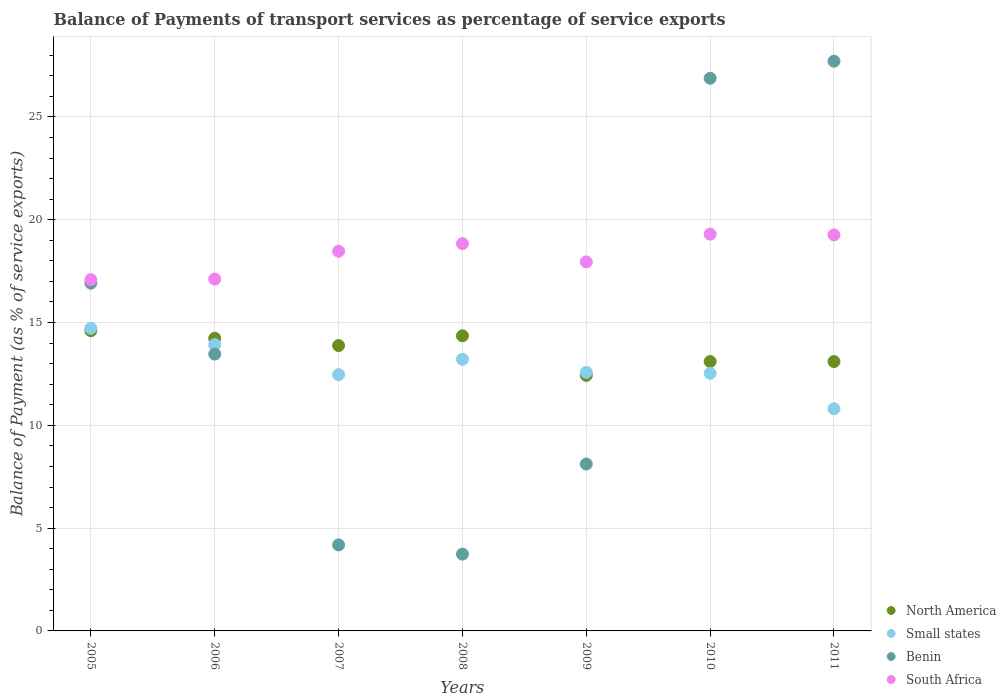What is the balance of payments of transport services in North America in 2010?
Your answer should be very brief. 13.1. Across all years, what is the maximum balance of payments of transport services in South Africa?
Provide a short and direct response. 19.3. Across all years, what is the minimum balance of payments of transport services in North America?
Your answer should be compact. 12.43. In which year was the balance of payments of transport services in North America maximum?
Keep it short and to the point. 2005. What is the total balance of payments of transport services in North America in the graph?
Your answer should be compact. 95.7. What is the difference between the balance of payments of transport services in Benin in 2005 and that in 2008?
Offer a terse response. 13.18. What is the difference between the balance of payments of transport services in Benin in 2005 and the balance of payments of transport services in South Africa in 2008?
Provide a succinct answer. -1.92. What is the average balance of payments of transport services in South Africa per year?
Ensure brevity in your answer.  18.29. In the year 2008, what is the difference between the balance of payments of transport services in Benin and balance of payments of transport services in Small states?
Ensure brevity in your answer.  -9.47. In how many years, is the balance of payments of transport services in South Africa greater than 8 %?
Offer a very short reply. 7. What is the ratio of the balance of payments of transport services in Small states in 2008 to that in 2009?
Ensure brevity in your answer.  1.05. Is the balance of payments of transport services in South Africa in 2008 less than that in 2010?
Offer a terse response. Yes. What is the difference between the highest and the second highest balance of payments of transport services in North America?
Make the answer very short. 0.24. What is the difference between the highest and the lowest balance of payments of transport services in Small states?
Keep it short and to the point. 3.91. Is it the case that in every year, the sum of the balance of payments of transport services in North America and balance of payments of transport services in Small states  is greater than the sum of balance of payments of transport services in Benin and balance of payments of transport services in South Africa?
Your answer should be very brief. Yes. Is it the case that in every year, the sum of the balance of payments of transport services in North America and balance of payments of transport services in South Africa  is greater than the balance of payments of transport services in Benin?
Offer a very short reply. Yes. Is the balance of payments of transport services in South Africa strictly greater than the balance of payments of transport services in Benin over the years?
Keep it short and to the point. No. Is the balance of payments of transport services in Small states strictly less than the balance of payments of transport services in North America over the years?
Offer a very short reply. No. How many dotlines are there?
Offer a very short reply. 4. Are the values on the major ticks of Y-axis written in scientific E-notation?
Give a very brief answer. No. What is the title of the graph?
Keep it short and to the point. Balance of Payments of transport services as percentage of service exports. What is the label or title of the Y-axis?
Keep it short and to the point. Balance of Payment (as % of service exports). What is the Balance of Payment (as % of service exports) of North America in 2005?
Keep it short and to the point. 14.6. What is the Balance of Payment (as % of service exports) of Small states in 2005?
Your answer should be very brief. 14.72. What is the Balance of Payment (as % of service exports) in Benin in 2005?
Offer a terse response. 16.92. What is the Balance of Payment (as % of service exports) of South Africa in 2005?
Make the answer very short. 17.08. What is the Balance of Payment (as % of service exports) in North America in 2006?
Provide a short and direct response. 14.23. What is the Balance of Payment (as % of service exports) of Small states in 2006?
Provide a short and direct response. 13.92. What is the Balance of Payment (as % of service exports) in Benin in 2006?
Your response must be concise. 13.46. What is the Balance of Payment (as % of service exports) of South Africa in 2006?
Your answer should be very brief. 17.11. What is the Balance of Payment (as % of service exports) in North America in 2007?
Keep it short and to the point. 13.88. What is the Balance of Payment (as % of service exports) in Small states in 2007?
Make the answer very short. 12.46. What is the Balance of Payment (as % of service exports) of Benin in 2007?
Provide a succinct answer. 4.18. What is the Balance of Payment (as % of service exports) in South Africa in 2007?
Provide a short and direct response. 18.47. What is the Balance of Payment (as % of service exports) in North America in 2008?
Give a very brief answer. 14.35. What is the Balance of Payment (as % of service exports) in Small states in 2008?
Your answer should be very brief. 13.21. What is the Balance of Payment (as % of service exports) in Benin in 2008?
Your answer should be compact. 3.73. What is the Balance of Payment (as % of service exports) of South Africa in 2008?
Ensure brevity in your answer.  18.84. What is the Balance of Payment (as % of service exports) of North America in 2009?
Offer a terse response. 12.43. What is the Balance of Payment (as % of service exports) in Small states in 2009?
Your answer should be very brief. 12.58. What is the Balance of Payment (as % of service exports) of Benin in 2009?
Offer a very short reply. 8.12. What is the Balance of Payment (as % of service exports) in South Africa in 2009?
Your answer should be compact. 17.95. What is the Balance of Payment (as % of service exports) in North America in 2010?
Make the answer very short. 13.1. What is the Balance of Payment (as % of service exports) in Small states in 2010?
Your answer should be compact. 12.53. What is the Balance of Payment (as % of service exports) of Benin in 2010?
Provide a succinct answer. 26.88. What is the Balance of Payment (as % of service exports) in South Africa in 2010?
Make the answer very short. 19.3. What is the Balance of Payment (as % of service exports) in North America in 2011?
Provide a succinct answer. 13.1. What is the Balance of Payment (as % of service exports) of Small states in 2011?
Offer a terse response. 10.81. What is the Balance of Payment (as % of service exports) in Benin in 2011?
Your answer should be compact. 27.71. What is the Balance of Payment (as % of service exports) in South Africa in 2011?
Your answer should be very brief. 19.26. Across all years, what is the maximum Balance of Payment (as % of service exports) of North America?
Provide a short and direct response. 14.6. Across all years, what is the maximum Balance of Payment (as % of service exports) in Small states?
Your response must be concise. 14.72. Across all years, what is the maximum Balance of Payment (as % of service exports) in Benin?
Provide a short and direct response. 27.71. Across all years, what is the maximum Balance of Payment (as % of service exports) in South Africa?
Provide a short and direct response. 19.3. Across all years, what is the minimum Balance of Payment (as % of service exports) in North America?
Your answer should be compact. 12.43. Across all years, what is the minimum Balance of Payment (as % of service exports) in Small states?
Make the answer very short. 10.81. Across all years, what is the minimum Balance of Payment (as % of service exports) of Benin?
Offer a very short reply. 3.73. Across all years, what is the minimum Balance of Payment (as % of service exports) in South Africa?
Give a very brief answer. 17.08. What is the total Balance of Payment (as % of service exports) in North America in the graph?
Your answer should be compact. 95.7. What is the total Balance of Payment (as % of service exports) in Small states in the graph?
Your answer should be compact. 90.23. What is the total Balance of Payment (as % of service exports) of Benin in the graph?
Offer a terse response. 101.01. What is the total Balance of Payment (as % of service exports) in South Africa in the graph?
Provide a succinct answer. 128.01. What is the difference between the Balance of Payment (as % of service exports) of North America in 2005 and that in 2006?
Make the answer very short. 0.37. What is the difference between the Balance of Payment (as % of service exports) in Small states in 2005 and that in 2006?
Your response must be concise. 0.8. What is the difference between the Balance of Payment (as % of service exports) in Benin in 2005 and that in 2006?
Keep it short and to the point. 3.45. What is the difference between the Balance of Payment (as % of service exports) in South Africa in 2005 and that in 2006?
Provide a succinct answer. -0.03. What is the difference between the Balance of Payment (as % of service exports) in North America in 2005 and that in 2007?
Your answer should be compact. 0.72. What is the difference between the Balance of Payment (as % of service exports) of Small states in 2005 and that in 2007?
Provide a short and direct response. 2.26. What is the difference between the Balance of Payment (as % of service exports) of Benin in 2005 and that in 2007?
Offer a very short reply. 12.73. What is the difference between the Balance of Payment (as % of service exports) in South Africa in 2005 and that in 2007?
Provide a short and direct response. -1.38. What is the difference between the Balance of Payment (as % of service exports) in North America in 2005 and that in 2008?
Offer a terse response. 0.24. What is the difference between the Balance of Payment (as % of service exports) of Small states in 2005 and that in 2008?
Your answer should be very brief. 1.51. What is the difference between the Balance of Payment (as % of service exports) in Benin in 2005 and that in 2008?
Offer a very short reply. 13.18. What is the difference between the Balance of Payment (as % of service exports) of South Africa in 2005 and that in 2008?
Offer a very short reply. -1.75. What is the difference between the Balance of Payment (as % of service exports) of North America in 2005 and that in 2009?
Ensure brevity in your answer.  2.17. What is the difference between the Balance of Payment (as % of service exports) in Small states in 2005 and that in 2009?
Ensure brevity in your answer.  2.14. What is the difference between the Balance of Payment (as % of service exports) of Benin in 2005 and that in 2009?
Provide a succinct answer. 8.8. What is the difference between the Balance of Payment (as % of service exports) in South Africa in 2005 and that in 2009?
Provide a short and direct response. -0.87. What is the difference between the Balance of Payment (as % of service exports) in North America in 2005 and that in 2010?
Your response must be concise. 1.5. What is the difference between the Balance of Payment (as % of service exports) of Small states in 2005 and that in 2010?
Provide a succinct answer. 2.19. What is the difference between the Balance of Payment (as % of service exports) in Benin in 2005 and that in 2010?
Keep it short and to the point. -9.96. What is the difference between the Balance of Payment (as % of service exports) of South Africa in 2005 and that in 2010?
Give a very brief answer. -2.21. What is the difference between the Balance of Payment (as % of service exports) in North America in 2005 and that in 2011?
Make the answer very short. 1.5. What is the difference between the Balance of Payment (as % of service exports) in Small states in 2005 and that in 2011?
Provide a succinct answer. 3.91. What is the difference between the Balance of Payment (as % of service exports) of Benin in 2005 and that in 2011?
Give a very brief answer. -10.79. What is the difference between the Balance of Payment (as % of service exports) in South Africa in 2005 and that in 2011?
Provide a succinct answer. -2.18. What is the difference between the Balance of Payment (as % of service exports) in North America in 2006 and that in 2007?
Make the answer very short. 0.35. What is the difference between the Balance of Payment (as % of service exports) in Small states in 2006 and that in 2007?
Your answer should be compact. 1.46. What is the difference between the Balance of Payment (as % of service exports) of Benin in 2006 and that in 2007?
Make the answer very short. 9.28. What is the difference between the Balance of Payment (as % of service exports) of South Africa in 2006 and that in 2007?
Make the answer very short. -1.35. What is the difference between the Balance of Payment (as % of service exports) in North America in 2006 and that in 2008?
Offer a terse response. -0.12. What is the difference between the Balance of Payment (as % of service exports) in Small states in 2006 and that in 2008?
Provide a short and direct response. 0.71. What is the difference between the Balance of Payment (as % of service exports) of Benin in 2006 and that in 2008?
Your response must be concise. 9.73. What is the difference between the Balance of Payment (as % of service exports) in South Africa in 2006 and that in 2008?
Ensure brevity in your answer.  -1.72. What is the difference between the Balance of Payment (as % of service exports) of North America in 2006 and that in 2009?
Your answer should be compact. 1.8. What is the difference between the Balance of Payment (as % of service exports) of Small states in 2006 and that in 2009?
Offer a terse response. 1.35. What is the difference between the Balance of Payment (as % of service exports) in Benin in 2006 and that in 2009?
Provide a short and direct response. 5.35. What is the difference between the Balance of Payment (as % of service exports) in South Africa in 2006 and that in 2009?
Offer a very short reply. -0.83. What is the difference between the Balance of Payment (as % of service exports) of North America in 2006 and that in 2010?
Offer a terse response. 1.13. What is the difference between the Balance of Payment (as % of service exports) of Small states in 2006 and that in 2010?
Your answer should be compact. 1.39. What is the difference between the Balance of Payment (as % of service exports) in Benin in 2006 and that in 2010?
Keep it short and to the point. -13.42. What is the difference between the Balance of Payment (as % of service exports) of South Africa in 2006 and that in 2010?
Offer a very short reply. -2.18. What is the difference between the Balance of Payment (as % of service exports) in North America in 2006 and that in 2011?
Make the answer very short. 1.13. What is the difference between the Balance of Payment (as % of service exports) of Small states in 2006 and that in 2011?
Keep it short and to the point. 3.12. What is the difference between the Balance of Payment (as % of service exports) in Benin in 2006 and that in 2011?
Offer a very short reply. -14.25. What is the difference between the Balance of Payment (as % of service exports) of South Africa in 2006 and that in 2011?
Give a very brief answer. -2.15. What is the difference between the Balance of Payment (as % of service exports) of North America in 2007 and that in 2008?
Offer a very short reply. -0.48. What is the difference between the Balance of Payment (as % of service exports) of Small states in 2007 and that in 2008?
Provide a succinct answer. -0.75. What is the difference between the Balance of Payment (as % of service exports) of Benin in 2007 and that in 2008?
Your response must be concise. 0.45. What is the difference between the Balance of Payment (as % of service exports) of South Africa in 2007 and that in 2008?
Provide a succinct answer. -0.37. What is the difference between the Balance of Payment (as % of service exports) of North America in 2007 and that in 2009?
Make the answer very short. 1.45. What is the difference between the Balance of Payment (as % of service exports) of Small states in 2007 and that in 2009?
Your response must be concise. -0.11. What is the difference between the Balance of Payment (as % of service exports) of Benin in 2007 and that in 2009?
Offer a terse response. -3.94. What is the difference between the Balance of Payment (as % of service exports) of South Africa in 2007 and that in 2009?
Offer a terse response. 0.52. What is the difference between the Balance of Payment (as % of service exports) of North America in 2007 and that in 2010?
Make the answer very short. 0.78. What is the difference between the Balance of Payment (as % of service exports) in Small states in 2007 and that in 2010?
Keep it short and to the point. -0.07. What is the difference between the Balance of Payment (as % of service exports) of Benin in 2007 and that in 2010?
Give a very brief answer. -22.7. What is the difference between the Balance of Payment (as % of service exports) in South Africa in 2007 and that in 2010?
Your answer should be very brief. -0.83. What is the difference between the Balance of Payment (as % of service exports) of North America in 2007 and that in 2011?
Ensure brevity in your answer.  0.78. What is the difference between the Balance of Payment (as % of service exports) in Small states in 2007 and that in 2011?
Make the answer very short. 1.66. What is the difference between the Balance of Payment (as % of service exports) in Benin in 2007 and that in 2011?
Your response must be concise. -23.53. What is the difference between the Balance of Payment (as % of service exports) in South Africa in 2007 and that in 2011?
Your response must be concise. -0.79. What is the difference between the Balance of Payment (as % of service exports) in North America in 2008 and that in 2009?
Keep it short and to the point. 1.93. What is the difference between the Balance of Payment (as % of service exports) of Small states in 2008 and that in 2009?
Your answer should be very brief. 0.63. What is the difference between the Balance of Payment (as % of service exports) of Benin in 2008 and that in 2009?
Your answer should be compact. -4.38. What is the difference between the Balance of Payment (as % of service exports) in South Africa in 2008 and that in 2009?
Give a very brief answer. 0.89. What is the difference between the Balance of Payment (as % of service exports) in North America in 2008 and that in 2010?
Provide a short and direct response. 1.25. What is the difference between the Balance of Payment (as % of service exports) in Small states in 2008 and that in 2010?
Offer a terse response. 0.68. What is the difference between the Balance of Payment (as % of service exports) in Benin in 2008 and that in 2010?
Make the answer very short. -23.15. What is the difference between the Balance of Payment (as % of service exports) in South Africa in 2008 and that in 2010?
Provide a succinct answer. -0.46. What is the difference between the Balance of Payment (as % of service exports) in North America in 2008 and that in 2011?
Your response must be concise. 1.25. What is the difference between the Balance of Payment (as % of service exports) of Small states in 2008 and that in 2011?
Keep it short and to the point. 2.4. What is the difference between the Balance of Payment (as % of service exports) of Benin in 2008 and that in 2011?
Keep it short and to the point. -23.97. What is the difference between the Balance of Payment (as % of service exports) in South Africa in 2008 and that in 2011?
Give a very brief answer. -0.43. What is the difference between the Balance of Payment (as % of service exports) in North America in 2009 and that in 2010?
Your answer should be very brief. -0.67. What is the difference between the Balance of Payment (as % of service exports) in Small states in 2009 and that in 2010?
Make the answer very short. 0.04. What is the difference between the Balance of Payment (as % of service exports) of Benin in 2009 and that in 2010?
Your answer should be very brief. -18.76. What is the difference between the Balance of Payment (as % of service exports) of South Africa in 2009 and that in 2010?
Your answer should be very brief. -1.35. What is the difference between the Balance of Payment (as % of service exports) of North America in 2009 and that in 2011?
Your answer should be compact. -0.67. What is the difference between the Balance of Payment (as % of service exports) in Small states in 2009 and that in 2011?
Offer a very short reply. 1.77. What is the difference between the Balance of Payment (as % of service exports) of Benin in 2009 and that in 2011?
Offer a terse response. -19.59. What is the difference between the Balance of Payment (as % of service exports) of South Africa in 2009 and that in 2011?
Provide a short and direct response. -1.31. What is the difference between the Balance of Payment (as % of service exports) in North America in 2010 and that in 2011?
Give a very brief answer. 0. What is the difference between the Balance of Payment (as % of service exports) of Small states in 2010 and that in 2011?
Offer a terse response. 1.73. What is the difference between the Balance of Payment (as % of service exports) of Benin in 2010 and that in 2011?
Offer a terse response. -0.83. What is the difference between the Balance of Payment (as % of service exports) of South Africa in 2010 and that in 2011?
Keep it short and to the point. 0.03. What is the difference between the Balance of Payment (as % of service exports) in North America in 2005 and the Balance of Payment (as % of service exports) in Small states in 2006?
Provide a succinct answer. 0.68. What is the difference between the Balance of Payment (as % of service exports) in North America in 2005 and the Balance of Payment (as % of service exports) in Benin in 2006?
Give a very brief answer. 1.13. What is the difference between the Balance of Payment (as % of service exports) of North America in 2005 and the Balance of Payment (as % of service exports) of South Africa in 2006?
Your response must be concise. -2.52. What is the difference between the Balance of Payment (as % of service exports) of Small states in 2005 and the Balance of Payment (as % of service exports) of Benin in 2006?
Keep it short and to the point. 1.26. What is the difference between the Balance of Payment (as % of service exports) in Small states in 2005 and the Balance of Payment (as % of service exports) in South Africa in 2006?
Your response must be concise. -2.39. What is the difference between the Balance of Payment (as % of service exports) of Benin in 2005 and the Balance of Payment (as % of service exports) of South Africa in 2006?
Keep it short and to the point. -0.2. What is the difference between the Balance of Payment (as % of service exports) in North America in 2005 and the Balance of Payment (as % of service exports) in Small states in 2007?
Make the answer very short. 2.13. What is the difference between the Balance of Payment (as % of service exports) of North America in 2005 and the Balance of Payment (as % of service exports) of Benin in 2007?
Provide a short and direct response. 10.42. What is the difference between the Balance of Payment (as % of service exports) in North America in 2005 and the Balance of Payment (as % of service exports) in South Africa in 2007?
Offer a very short reply. -3.87. What is the difference between the Balance of Payment (as % of service exports) of Small states in 2005 and the Balance of Payment (as % of service exports) of Benin in 2007?
Offer a very short reply. 10.54. What is the difference between the Balance of Payment (as % of service exports) of Small states in 2005 and the Balance of Payment (as % of service exports) of South Africa in 2007?
Your response must be concise. -3.75. What is the difference between the Balance of Payment (as % of service exports) of Benin in 2005 and the Balance of Payment (as % of service exports) of South Africa in 2007?
Your response must be concise. -1.55. What is the difference between the Balance of Payment (as % of service exports) in North America in 2005 and the Balance of Payment (as % of service exports) in Small states in 2008?
Your answer should be compact. 1.39. What is the difference between the Balance of Payment (as % of service exports) of North America in 2005 and the Balance of Payment (as % of service exports) of Benin in 2008?
Ensure brevity in your answer.  10.86. What is the difference between the Balance of Payment (as % of service exports) in North America in 2005 and the Balance of Payment (as % of service exports) in South Africa in 2008?
Provide a short and direct response. -4.24. What is the difference between the Balance of Payment (as % of service exports) of Small states in 2005 and the Balance of Payment (as % of service exports) of Benin in 2008?
Keep it short and to the point. 10.99. What is the difference between the Balance of Payment (as % of service exports) of Small states in 2005 and the Balance of Payment (as % of service exports) of South Africa in 2008?
Give a very brief answer. -4.12. What is the difference between the Balance of Payment (as % of service exports) in Benin in 2005 and the Balance of Payment (as % of service exports) in South Africa in 2008?
Your answer should be very brief. -1.92. What is the difference between the Balance of Payment (as % of service exports) in North America in 2005 and the Balance of Payment (as % of service exports) in Small states in 2009?
Provide a succinct answer. 2.02. What is the difference between the Balance of Payment (as % of service exports) in North America in 2005 and the Balance of Payment (as % of service exports) in Benin in 2009?
Ensure brevity in your answer.  6.48. What is the difference between the Balance of Payment (as % of service exports) in North America in 2005 and the Balance of Payment (as % of service exports) in South Africa in 2009?
Give a very brief answer. -3.35. What is the difference between the Balance of Payment (as % of service exports) in Small states in 2005 and the Balance of Payment (as % of service exports) in Benin in 2009?
Give a very brief answer. 6.6. What is the difference between the Balance of Payment (as % of service exports) of Small states in 2005 and the Balance of Payment (as % of service exports) of South Africa in 2009?
Your answer should be compact. -3.23. What is the difference between the Balance of Payment (as % of service exports) of Benin in 2005 and the Balance of Payment (as % of service exports) of South Africa in 2009?
Offer a very short reply. -1.03. What is the difference between the Balance of Payment (as % of service exports) in North America in 2005 and the Balance of Payment (as % of service exports) in Small states in 2010?
Your answer should be compact. 2.07. What is the difference between the Balance of Payment (as % of service exports) of North America in 2005 and the Balance of Payment (as % of service exports) of Benin in 2010?
Your answer should be compact. -12.28. What is the difference between the Balance of Payment (as % of service exports) in North America in 2005 and the Balance of Payment (as % of service exports) in South Africa in 2010?
Give a very brief answer. -4.7. What is the difference between the Balance of Payment (as % of service exports) of Small states in 2005 and the Balance of Payment (as % of service exports) of Benin in 2010?
Keep it short and to the point. -12.16. What is the difference between the Balance of Payment (as % of service exports) of Small states in 2005 and the Balance of Payment (as % of service exports) of South Africa in 2010?
Offer a very short reply. -4.58. What is the difference between the Balance of Payment (as % of service exports) of Benin in 2005 and the Balance of Payment (as % of service exports) of South Africa in 2010?
Make the answer very short. -2.38. What is the difference between the Balance of Payment (as % of service exports) of North America in 2005 and the Balance of Payment (as % of service exports) of Small states in 2011?
Offer a terse response. 3.79. What is the difference between the Balance of Payment (as % of service exports) in North America in 2005 and the Balance of Payment (as % of service exports) in Benin in 2011?
Keep it short and to the point. -13.11. What is the difference between the Balance of Payment (as % of service exports) of North America in 2005 and the Balance of Payment (as % of service exports) of South Africa in 2011?
Keep it short and to the point. -4.66. What is the difference between the Balance of Payment (as % of service exports) of Small states in 2005 and the Balance of Payment (as % of service exports) of Benin in 2011?
Give a very brief answer. -12.99. What is the difference between the Balance of Payment (as % of service exports) in Small states in 2005 and the Balance of Payment (as % of service exports) in South Africa in 2011?
Keep it short and to the point. -4.54. What is the difference between the Balance of Payment (as % of service exports) in Benin in 2005 and the Balance of Payment (as % of service exports) in South Africa in 2011?
Your response must be concise. -2.35. What is the difference between the Balance of Payment (as % of service exports) in North America in 2006 and the Balance of Payment (as % of service exports) in Small states in 2007?
Offer a very short reply. 1.77. What is the difference between the Balance of Payment (as % of service exports) of North America in 2006 and the Balance of Payment (as % of service exports) of Benin in 2007?
Make the answer very short. 10.05. What is the difference between the Balance of Payment (as % of service exports) of North America in 2006 and the Balance of Payment (as % of service exports) of South Africa in 2007?
Ensure brevity in your answer.  -4.24. What is the difference between the Balance of Payment (as % of service exports) in Small states in 2006 and the Balance of Payment (as % of service exports) in Benin in 2007?
Your answer should be compact. 9.74. What is the difference between the Balance of Payment (as % of service exports) in Small states in 2006 and the Balance of Payment (as % of service exports) in South Africa in 2007?
Provide a short and direct response. -4.54. What is the difference between the Balance of Payment (as % of service exports) of Benin in 2006 and the Balance of Payment (as % of service exports) of South Africa in 2007?
Your answer should be very brief. -5. What is the difference between the Balance of Payment (as % of service exports) in North America in 2006 and the Balance of Payment (as % of service exports) in Small states in 2008?
Keep it short and to the point. 1.02. What is the difference between the Balance of Payment (as % of service exports) of North America in 2006 and the Balance of Payment (as % of service exports) of Benin in 2008?
Your answer should be compact. 10.5. What is the difference between the Balance of Payment (as % of service exports) in North America in 2006 and the Balance of Payment (as % of service exports) in South Africa in 2008?
Offer a very short reply. -4.6. What is the difference between the Balance of Payment (as % of service exports) in Small states in 2006 and the Balance of Payment (as % of service exports) in Benin in 2008?
Provide a succinct answer. 10.19. What is the difference between the Balance of Payment (as % of service exports) of Small states in 2006 and the Balance of Payment (as % of service exports) of South Africa in 2008?
Your answer should be very brief. -4.91. What is the difference between the Balance of Payment (as % of service exports) in Benin in 2006 and the Balance of Payment (as % of service exports) in South Africa in 2008?
Make the answer very short. -5.37. What is the difference between the Balance of Payment (as % of service exports) in North America in 2006 and the Balance of Payment (as % of service exports) in Small states in 2009?
Ensure brevity in your answer.  1.66. What is the difference between the Balance of Payment (as % of service exports) in North America in 2006 and the Balance of Payment (as % of service exports) in Benin in 2009?
Ensure brevity in your answer.  6.11. What is the difference between the Balance of Payment (as % of service exports) of North America in 2006 and the Balance of Payment (as % of service exports) of South Africa in 2009?
Ensure brevity in your answer.  -3.72. What is the difference between the Balance of Payment (as % of service exports) in Small states in 2006 and the Balance of Payment (as % of service exports) in Benin in 2009?
Ensure brevity in your answer.  5.81. What is the difference between the Balance of Payment (as % of service exports) of Small states in 2006 and the Balance of Payment (as % of service exports) of South Africa in 2009?
Provide a succinct answer. -4.03. What is the difference between the Balance of Payment (as % of service exports) in Benin in 2006 and the Balance of Payment (as % of service exports) in South Africa in 2009?
Your answer should be compact. -4.48. What is the difference between the Balance of Payment (as % of service exports) in North America in 2006 and the Balance of Payment (as % of service exports) in Small states in 2010?
Your answer should be very brief. 1.7. What is the difference between the Balance of Payment (as % of service exports) in North America in 2006 and the Balance of Payment (as % of service exports) in Benin in 2010?
Your answer should be very brief. -12.65. What is the difference between the Balance of Payment (as % of service exports) of North America in 2006 and the Balance of Payment (as % of service exports) of South Africa in 2010?
Offer a very short reply. -5.06. What is the difference between the Balance of Payment (as % of service exports) in Small states in 2006 and the Balance of Payment (as % of service exports) in Benin in 2010?
Ensure brevity in your answer.  -12.96. What is the difference between the Balance of Payment (as % of service exports) of Small states in 2006 and the Balance of Payment (as % of service exports) of South Africa in 2010?
Your response must be concise. -5.37. What is the difference between the Balance of Payment (as % of service exports) in Benin in 2006 and the Balance of Payment (as % of service exports) in South Africa in 2010?
Provide a short and direct response. -5.83. What is the difference between the Balance of Payment (as % of service exports) of North America in 2006 and the Balance of Payment (as % of service exports) of Small states in 2011?
Your answer should be compact. 3.43. What is the difference between the Balance of Payment (as % of service exports) in North America in 2006 and the Balance of Payment (as % of service exports) in Benin in 2011?
Provide a succinct answer. -13.48. What is the difference between the Balance of Payment (as % of service exports) in North America in 2006 and the Balance of Payment (as % of service exports) in South Africa in 2011?
Your response must be concise. -5.03. What is the difference between the Balance of Payment (as % of service exports) in Small states in 2006 and the Balance of Payment (as % of service exports) in Benin in 2011?
Your answer should be very brief. -13.79. What is the difference between the Balance of Payment (as % of service exports) of Small states in 2006 and the Balance of Payment (as % of service exports) of South Africa in 2011?
Ensure brevity in your answer.  -5.34. What is the difference between the Balance of Payment (as % of service exports) of Benin in 2006 and the Balance of Payment (as % of service exports) of South Africa in 2011?
Provide a short and direct response. -5.8. What is the difference between the Balance of Payment (as % of service exports) in North America in 2007 and the Balance of Payment (as % of service exports) in Small states in 2008?
Keep it short and to the point. 0.67. What is the difference between the Balance of Payment (as % of service exports) in North America in 2007 and the Balance of Payment (as % of service exports) in Benin in 2008?
Offer a very short reply. 10.14. What is the difference between the Balance of Payment (as % of service exports) of North America in 2007 and the Balance of Payment (as % of service exports) of South Africa in 2008?
Make the answer very short. -4.96. What is the difference between the Balance of Payment (as % of service exports) in Small states in 2007 and the Balance of Payment (as % of service exports) in Benin in 2008?
Provide a succinct answer. 8.73. What is the difference between the Balance of Payment (as % of service exports) of Small states in 2007 and the Balance of Payment (as % of service exports) of South Africa in 2008?
Offer a very short reply. -6.37. What is the difference between the Balance of Payment (as % of service exports) of Benin in 2007 and the Balance of Payment (as % of service exports) of South Africa in 2008?
Your answer should be very brief. -14.65. What is the difference between the Balance of Payment (as % of service exports) in North America in 2007 and the Balance of Payment (as % of service exports) in Small states in 2009?
Provide a short and direct response. 1.3. What is the difference between the Balance of Payment (as % of service exports) of North America in 2007 and the Balance of Payment (as % of service exports) of Benin in 2009?
Provide a succinct answer. 5.76. What is the difference between the Balance of Payment (as % of service exports) in North America in 2007 and the Balance of Payment (as % of service exports) in South Africa in 2009?
Offer a very short reply. -4.07. What is the difference between the Balance of Payment (as % of service exports) of Small states in 2007 and the Balance of Payment (as % of service exports) of Benin in 2009?
Your answer should be compact. 4.35. What is the difference between the Balance of Payment (as % of service exports) in Small states in 2007 and the Balance of Payment (as % of service exports) in South Africa in 2009?
Provide a succinct answer. -5.48. What is the difference between the Balance of Payment (as % of service exports) in Benin in 2007 and the Balance of Payment (as % of service exports) in South Africa in 2009?
Provide a short and direct response. -13.77. What is the difference between the Balance of Payment (as % of service exports) in North America in 2007 and the Balance of Payment (as % of service exports) in Small states in 2010?
Offer a very short reply. 1.35. What is the difference between the Balance of Payment (as % of service exports) in North America in 2007 and the Balance of Payment (as % of service exports) in Benin in 2010?
Provide a succinct answer. -13. What is the difference between the Balance of Payment (as % of service exports) in North America in 2007 and the Balance of Payment (as % of service exports) in South Africa in 2010?
Your response must be concise. -5.42. What is the difference between the Balance of Payment (as % of service exports) in Small states in 2007 and the Balance of Payment (as % of service exports) in Benin in 2010?
Your answer should be compact. -14.42. What is the difference between the Balance of Payment (as % of service exports) in Small states in 2007 and the Balance of Payment (as % of service exports) in South Africa in 2010?
Keep it short and to the point. -6.83. What is the difference between the Balance of Payment (as % of service exports) in Benin in 2007 and the Balance of Payment (as % of service exports) in South Africa in 2010?
Make the answer very short. -15.11. What is the difference between the Balance of Payment (as % of service exports) of North America in 2007 and the Balance of Payment (as % of service exports) of Small states in 2011?
Make the answer very short. 3.07. What is the difference between the Balance of Payment (as % of service exports) of North America in 2007 and the Balance of Payment (as % of service exports) of Benin in 2011?
Offer a very short reply. -13.83. What is the difference between the Balance of Payment (as % of service exports) of North America in 2007 and the Balance of Payment (as % of service exports) of South Africa in 2011?
Keep it short and to the point. -5.38. What is the difference between the Balance of Payment (as % of service exports) of Small states in 2007 and the Balance of Payment (as % of service exports) of Benin in 2011?
Make the answer very short. -15.25. What is the difference between the Balance of Payment (as % of service exports) of Small states in 2007 and the Balance of Payment (as % of service exports) of South Africa in 2011?
Offer a terse response. -6.8. What is the difference between the Balance of Payment (as % of service exports) in Benin in 2007 and the Balance of Payment (as % of service exports) in South Africa in 2011?
Make the answer very short. -15.08. What is the difference between the Balance of Payment (as % of service exports) of North America in 2008 and the Balance of Payment (as % of service exports) of Small states in 2009?
Give a very brief answer. 1.78. What is the difference between the Balance of Payment (as % of service exports) of North America in 2008 and the Balance of Payment (as % of service exports) of Benin in 2009?
Make the answer very short. 6.24. What is the difference between the Balance of Payment (as % of service exports) of North America in 2008 and the Balance of Payment (as % of service exports) of South Africa in 2009?
Ensure brevity in your answer.  -3.59. What is the difference between the Balance of Payment (as % of service exports) in Small states in 2008 and the Balance of Payment (as % of service exports) in Benin in 2009?
Give a very brief answer. 5.09. What is the difference between the Balance of Payment (as % of service exports) of Small states in 2008 and the Balance of Payment (as % of service exports) of South Africa in 2009?
Make the answer very short. -4.74. What is the difference between the Balance of Payment (as % of service exports) of Benin in 2008 and the Balance of Payment (as % of service exports) of South Africa in 2009?
Ensure brevity in your answer.  -14.21. What is the difference between the Balance of Payment (as % of service exports) in North America in 2008 and the Balance of Payment (as % of service exports) in Small states in 2010?
Provide a short and direct response. 1.82. What is the difference between the Balance of Payment (as % of service exports) in North America in 2008 and the Balance of Payment (as % of service exports) in Benin in 2010?
Give a very brief answer. -12.53. What is the difference between the Balance of Payment (as % of service exports) of North America in 2008 and the Balance of Payment (as % of service exports) of South Africa in 2010?
Offer a very short reply. -4.94. What is the difference between the Balance of Payment (as % of service exports) of Small states in 2008 and the Balance of Payment (as % of service exports) of Benin in 2010?
Your answer should be compact. -13.67. What is the difference between the Balance of Payment (as % of service exports) of Small states in 2008 and the Balance of Payment (as % of service exports) of South Africa in 2010?
Your answer should be compact. -6.09. What is the difference between the Balance of Payment (as % of service exports) of Benin in 2008 and the Balance of Payment (as % of service exports) of South Africa in 2010?
Your answer should be compact. -15.56. What is the difference between the Balance of Payment (as % of service exports) in North America in 2008 and the Balance of Payment (as % of service exports) in Small states in 2011?
Make the answer very short. 3.55. What is the difference between the Balance of Payment (as % of service exports) of North America in 2008 and the Balance of Payment (as % of service exports) of Benin in 2011?
Offer a terse response. -13.35. What is the difference between the Balance of Payment (as % of service exports) in North America in 2008 and the Balance of Payment (as % of service exports) in South Africa in 2011?
Keep it short and to the point. -4.91. What is the difference between the Balance of Payment (as % of service exports) in Small states in 2008 and the Balance of Payment (as % of service exports) in Benin in 2011?
Your response must be concise. -14.5. What is the difference between the Balance of Payment (as % of service exports) of Small states in 2008 and the Balance of Payment (as % of service exports) of South Africa in 2011?
Your answer should be very brief. -6.05. What is the difference between the Balance of Payment (as % of service exports) in Benin in 2008 and the Balance of Payment (as % of service exports) in South Africa in 2011?
Offer a terse response. -15.53. What is the difference between the Balance of Payment (as % of service exports) of North America in 2009 and the Balance of Payment (as % of service exports) of Small states in 2010?
Offer a terse response. -0.1. What is the difference between the Balance of Payment (as % of service exports) of North America in 2009 and the Balance of Payment (as % of service exports) of Benin in 2010?
Make the answer very short. -14.45. What is the difference between the Balance of Payment (as % of service exports) in North America in 2009 and the Balance of Payment (as % of service exports) in South Africa in 2010?
Give a very brief answer. -6.87. What is the difference between the Balance of Payment (as % of service exports) in Small states in 2009 and the Balance of Payment (as % of service exports) in Benin in 2010?
Your response must be concise. -14.3. What is the difference between the Balance of Payment (as % of service exports) of Small states in 2009 and the Balance of Payment (as % of service exports) of South Africa in 2010?
Make the answer very short. -6.72. What is the difference between the Balance of Payment (as % of service exports) in Benin in 2009 and the Balance of Payment (as % of service exports) in South Africa in 2010?
Ensure brevity in your answer.  -11.18. What is the difference between the Balance of Payment (as % of service exports) of North America in 2009 and the Balance of Payment (as % of service exports) of Small states in 2011?
Make the answer very short. 1.62. What is the difference between the Balance of Payment (as % of service exports) of North America in 2009 and the Balance of Payment (as % of service exports) of Benin in 2011?
Your answer should be very brief. -15.28. What is the difference between the Balance of Payment (as % of service exports) in North America in 2009 and the Balance of Payment (as % of service exports) in South Africa in 2011?
Provide a short and direct response. -6.83. What is the difference between the Balance of Payment (as % of service exports) of Small states in 2009 and the Balance of Payment (as % of service exports) of Benin in 2011?
Give a very brief answer. -15.13. What is the difference between the Balance of Payment (as % of service exports) of Small states in 2009 and the Balance of Payment (as % of service exports) of South Africa in 2011?
Offer a terse response. -6.69. What is the difference between the Balance of Payment (as % of service exports) in Benin in 2009 and the Balance of Payment (as % of service exports) in South Africa in 2011?
Your answer should be very brief. -11.14. What is the difference between the Balance of Payment (as % of service exports) of North America in 2010 and the Balance of Payment (as % of service exports) of Small states in 2011?
Keep it short and to the point. 2.3. What is the difference between the Balance of Payment (as % of service exports) of North America in 2010 and the Balance of Payment (as % of service exports) of Benin in 2011?
Offer a terse response. -14.61. What is the difference between the Balance of Payment (as % of service exports) of North America in 2010 and the Balance of Payment (as % of service exports) of South Africa in 2011?
Your answer should be compact. -6.16. What is the difference between the Balance of Payment (as % of service exports) in Small states in 2010 and the Balance of Payment (as % of service exports) in Benin in 2011?
Your response must be concise. -15.18. What is the difference between the Balance of Payment (as % of service exports) in Small states in 2010 and the Balance of Payment (as % of service exports) in South Africa in 2011?
Provide a short and direct response. -6.73. What is the difference between the Balance of Payment (as % of service exports) in Benin in 2010 and the Balance of Payment (as % of service exports) in South Africa in 2011?
Provide a succinct answer. 7.62. What is the average Balance of Payment (as % of service exports) of North America per year?
Keep it short and to the point. 13.67. What is the average Balance of Payment (as % of service exports) of Small states per year?
Offer a terse response. 12.89. What is the average Balance of Payment (as % of service exports) of Benin per year?
Offer a very short reply. 14.43. What is the average Balance of Payment (as % of service exports) in South Africa per year?
Give a very brief answer. 18.29. In the year 2005, what is the difference between the Balance of Payment (as % of service exports) in North America and Balance of Payment (as % of service exports) in Small states?
Provide a short and direct response. -0.12. In the year 2005, what is the difference between the Balance of Payment (as % of service exports) of North America and Balance of Payment (as % of service exports) of Benin?
Offer a very short reply. -2.32. In the year 2005, what is the difference between the Balance of Payment (as % of service exports) in North America and Balance of Payment (as % of service exports) in South Africa?
Make the answer very short. -2.48. In the year 2005, what is the difference between the Balance of Payment (as % of service exports) in Small states and Balance of Payment (as % of service exports) in Benin?
Provide a succinct answer. -2.2. In the year 2005, what is the difference between the Balance of Payment (as % of service exports) of Small states and Balance of Payment (as % of service exports) of South Africa?
Your answer should be very brief. -2.36. In the year 2005, what is the difference between the Balance of Payment (as % of service exports) in Benin and Balance of Payment (as % of service exports) in South Africa?
Provide a short and direct response. -0.17. In the year 2006, what is the difference between the Balance of Payment (as % of service exports) in North America and Balance of Payment (as % of service exports) in Small states?
Keep it short and to the point. 0.31. In the year 2006, what is the difference between the Balance of Payment (as % of service exports) in North America and Balance of Payment (as % of service exports) in Benin?
Your answer should be very brief. 0.77. In the year 2006, what is the difference between the Balance of Payment (as % of service exports) of North America and Balance of Payment (as % of service exports) of South Africa?
Offer a very short reply. -2.88. In the year 2006, what is the difference between the Balance of Payment (as % of service exports) of Small states and Balance of Payment (as % of service exports) of Benin?
Give a very brief answer. 0.46. In the year 2006, what is the difference between the Balance of Payment (as % of service exports) of Small states and Balance of Payment (as % of service exports) of South Africa?
Offer a terse response. -3.19. In the year 2006, what is the difference between the Balance of Payment (as % of service exports) in Benin and Balance of Payment (as % of service exports) in South Africa?
Offer a very short reply. -3.65. In the year 2007, what is the difference between the Balance of Payment (as % of service exports) of North America and Balance of Payment (as % of service exports) of Small states?
Offer a very short reply. 1.41. In the year 2007, what is the difference between the Balance of Payment (as % of service exports) in North America and Balance of Payment (as % of service exports) in Benin?
Give a very brief answer. 9.7. In the year 2007, what is the difference between the Balance of Payment (as % of service exports) of North America and Balance of Payment (as % of service exports) of South Africa?
Ensure brevity in your answer.  -4.59. In the year 2007, what is the difference between the Balance of Payment (as % of service exports) in Small states and Balance of Payment (as % of service exports) in Benin?
Give a very brief answer. 8.28. In the year 2007, what is the difference between the Balance of Payment (as % of service exports) in Small states and Balance of Payment (as % of service exports) in South Africa?
Your answer should be compact. -6. In the year 2007, what is the difference between the Balance of Payment (as % of service exports) in Benin and Balance of Payment (as % of service exports) in South Africa?
Offer a very short reply. -14.29. In the year 2008, what is the difference between the Balance of Payment (as % of service exports) in North America and Balance of Payment (as % of service exports) in Small states?
Provide a succinct answer. 1.14. In the year 2008, what is the difference between the Balance of Payment (as % of service exports) of North America and Balance of Payment (as % of service exports) of Benin?
Provide a succinct answer. 10.62. In the year 2008, what is the difference between the Balance of Payment (as % of service exports) in North America and Balance of Payment (as % of service exports) in South Africa?
Keep it short and to the point. -4.48. In the year 2008, what is the difference between the Balance of Payment (as % of service exports) of Small states and Balance of Payment (as % of service exports) of Benin?
Provide a short and direct response. 9.47. In the year 2008, what is the difference between the Balance of Payment (as % of service exports) of Small states and Balance of Payment (as % of service exports) of South Africa?
Give a very brief answer. -5.63. In the year 2008, what is the difference between the Balance of Payment (as % of service exports) of Benin and Balance of Payment (as % of service exports) of South Africa?
Offer a terse response. -15.1. In the year 2009, what is the difference between the Balance of Payment (as % of service exports) of North America and Balance of Payment (as % of service exports) of Small states?
Provide a short and direct response. -0.15. In the year 2009, what is the difference between the Balance of Payment (as % of service exports) of North America and Balance of Payment (as % of service exports) of Benin?
Make the answer very short. 4.31. In the year 2009, what is the difference between the Balance of Payment (as % of service exports) in North America and Balance of Payment (as % of service exports) in South Africa?
Your answer should be compact. -5.52. In the year 2009, what is the difference between the Balance of Payment (as % of service exports) in Small states and Balance of Payment (as % of service exports) in Benin?
Make the answer very short. 4.46. In the year 2009, what is the difference between the Balance of Payment (as % of service exports) in Small states and Balance of Payment (as % of service exports) in South Africa?
Provide a short and direct response. -5.37. In the year 2009, what is the difference between the Balance of Payment (as % of service exports) of Benin and Balance of Payment (as % of service exports) of South Africa?
Your answer should be compact. -9.83. In the year 2010, what is the difference between the Balance of Payment (as % of service exports) in North America and Balance of Payment (as % of service exports) in Small states?
Make the answer very short. 0.57. In the year 2010, what is the difference between the Balance of Payment (as % of service exports) of North America and Balance of Payment (as % of service exports) of Benin?
Offer a very short reply. -13.78. In the year 2010, what is the difference between the Balance of Payment (as % of service exports) of North America and Balance of Payment (as % of service exports) of South Africa?
Provide a succinct answer. -6.19. In the year 2010, what is the difference between the Balance of Payment (as % of service exports) in Small states and Balance of Payment (as % of service exports) in Benin?
Make the answer very short. -14.35. In the year 2010, what is the difference between the Balance of Payment (as % of service exports) in Small states and Balance of Payment (as % of service exports) in South Africa?
Keep it short and to the point. -6.77. In the year 2010, what is the difference between the Balance of Payment (as % of service exports) of Benin and Balance of Payment (as % of service exports) of South Africa?
Your answer should be very brief. 7.58. In the year 2011, what is the difference between the Balance of Payment (as % of service exports) in North America and Balance of Payment (as % of service exports) in Small states?
Your answer should be very brief. 2.29. In the year 2011, what is the difference between the Balance of Payment (as % of service exports) of North America and Balance of Payment (as % of service exports) of Benin?
Provide a succinct answer. -14.61. In the year 2011, what is the difference between the Balance of Payment (as % of service exports) of North America and Balance of Payment (as % of service exports) of South Africa?
Offer a very short reply. -6.16. In the year 2011, what is the difference between the Balance of Payment (as % of service exports) of Small states and Balance of Payment (as % of service exports) of Benin?
Your answer should be very brief. -16.9. In the year 2011, what is the difference between the Balance of Payment (as % of service exports) of Small states and Balance of Payment (as % of service exports) of South Africa?
Offer a terse response. -8.46. In the year 2011, what is the difference between the Balance of Payment (as % of service exports) of Benin and Balance of Payment (as % of service exports) of South Africa?
Keep it short and to the point. 8.45. What is the ratio of the Balance of Payment (as % of service exports) in North America in 2005 to that in 2006?
Your answer should be compact. 1.03. What is the ratio of the Balance of Payment (as % of service exports) in Small states in 2005 to that in 2006?
Give a very brief answer. 1.06. What is the ratio of the Balance of Payment (as % of service exports) of Benin in 2005 to that in 2006?
Provide a succinct answer. 1.26. What is the ratio of the Balance of Payment (as % of service exports) of South Africa in 2005 to that in 2006?
Offer a terse response. 1. What is the ratio of the Balance of Payment (as % of service exports) of North America in 2005 to that in 2007?
Give a very brief answer. 1.05. What is the ratio of the Balance of Payment (as % of service exports) in Small states in 2005 to that in 2007?
Keep it short and to the point. 1.18. What is the ratio of the Balance of Payment (as % of service exports) in Benin in 2005 to that in 2007?
Keep it short and to the point. 4.04. What is the ratio of the Balance of Payment (as % of service exports) of South Africa in 2005 to that in 2007?
Your answer should be very brief. 0.93. What is the ratio of the Balance of Payment (as % of service exports) of Small states in 2005 to that in 2008?
Your answer should be compact. 1.11. What is the ratio of the Balance of Payment (as % of service exports) of Benin in 2005 to that in 2008?
Keep it short and to the point. 4.53. What is the ratio of the Balance of Payment (as % of service exports) in South Africa in 2005 to that in 2008?
Offer a very short reply. 0.91. What is the ratio of the Balance of Payment (as % of service exports) of North America in 2005 to that in 2009?
Make the answer very short. 1.17. What is the ratio of the Balance of Payment (as % of service exports) in Small states in 2005 to that in 2009?
Ensure brevity in your answer.  1.17. What is the ratio of the Balance of Payment (as % of service exports) of Benin in 2005 to that in 2009?
Offer a terse response. 2.08. What is the ratio of the Balance of Payment (as % of service exports) in South Africa in 2005 to that in 2009?
Keep it short and to the point. 0.95. What is the ratio of the Balance of Payment (as % of service exports) in North America in 2005 to that in 2010?
Your answer should be very brief. 1.11. What is the ratio of the Balance of Payment (as % of service exports) of Small states in 2005 to that in 2010?
Offer a terse response. 1.17. What is the ratio of the Balance of Payment (as % of service exports) in Benin in 2005 to that in 2010?
Ensure brevity in your answer.  0.63. What is the ratio of the Balance of Payment (as % of service exports) in South Africa in 2005 to that in 2010?
Keep it short and to the point. 0.89. What is the ratio of the Balance of Payment (as % of service exports) of North America in 2005 to that in 2011?
Keep it short and to the point. 1.11. What is the ratio of the Balance of Payment (as % of service exports) in Small states in 2005 to that in 2011?
Offer a very short reply. 1.36. What is the ratio of the Balance of Payment (as % of service exports) in Benin in 2005 to that in 2011?
Provide a short and direct response. 0.61. What is the ratio of the Balance of Payment (as % of service exports) in South Africa in 2005 to that in 2011?
Your answer should be very brief. 0.89. What is the ratio of the Balance of Payment (as % of service exports) in North America in 2006 to that in 2007?
Keep it short and to the point. 1.03. What is the ratio of the Balance of Payment (as % of service exports) of Small states in 2006 to that in 2007?
Make the answer very short. 1.12. What is the ratio of the Balance of Payment (as % of service exports) in Benin in 2006 to that in 2007?
Give a very brief answer. 3.22. What is the ratio of the Balance of Payment (as % of service exports) of South Africa in 2006 to that in 2007?
Offer a terse response. 0.93. What is the ratio of the Balance of Payment (as % of service exports) of Small states in 2006 to that in 2008?
Provide a succinct answer. 1.05. What is the ratio of the Balance of Payment (as % of service exports) in Benin in 2006 to that in 2008?
Provide a short and direct response. 3.6. What is the ratio of the Balance of Payment (as % of service exports) of South Africa in 2006 to that in 2008?
Offer a very short reply. 0.91. What is the ratio of the Balance of Payment (as % of service exports) of North America in 2006 to that in 2009?
Offer a terse response. 1.15. What is the ratio of the Balance of Payment (as % of service exports) of Small states in 2006 to that in 2009?
Provide a succinct answer. 1.11. What is the ratio of the Balance of Payment (as % of service exports) of Benin in 2006 to that in 2009?
Offer a very short reply. 1.66. What is the ratio of the Balance of Payment (as % of service exports) in South Africa in 2006 to that in 2009?
Give a very brief answer. 0.95. What is the ratio of the Balance of Payment (as % of service exports) in North America in 2006 to that in 2010?
Your response must be concise. 1.09. What is the ratio of the Balance of Payment (as % of service exports) in Small states in 2006 to that in 2010?
Your response must be concise. 1.11. What is the ratio of the Balance of Payment (as % of service exports) of Benin in 2006 to that in 2010?
Keep it short and to the point. 0.5. What is the ratio of the Balance of Payment (as % of service exports) of South Africa in 2006 to that in 2010?
Offer a terse response. 0.89. What is the ratio of the Balance of Payment (as % of service exports) in North America in 2006 to that in 2011?
Offer a very short reply. 1.09. What is the ratio of the Balance of Payment (as % of service exports) of Small states in 2006 to that in 2011?
Give a very brief answer. 1.29. What is the ratio of the Balance of Payment (as % of service exports) in Benin in 2006 to that in 2011?
Keep it short and to the point. 0.49. What is the ratio of the Balance of Payment (as % of service exports) in South Africa in 2006 to that in 2011?
Your answer should be compact. 0.89. What is the ratio of the Balance of Payment (as % of service exports) of North America in 2007 to that in 2008?
Your answer should be compact. 0.97. What is the ratio of the Balance of Payment (as % of service exports) in Small states in 2007 to that in 2008?
Provide a succinct answer. 0.94. What is the ratio of the Balance of Payment (as % of service exports) in Benin in 2007 to that in 2008?
Your response must be concise. 1.12. What is the ratio of the Balance of Payment (as % of service exports) in South Africa in 2007 to that in 2008?
Provide a succinct answer. 0.98. What is the ratio of the Balance of Payment (as % of service exports) of North America in 2007 to that in 2009?
Your response must be concise. 1.12. What is the ratio of the Balance of Payment (as % of service exports) of Benin in 2007 to that in 2009?
Give a very brief answer. 0.52. What is the ratio of the Balance of Payment (as % of service exports) in South Africa in 2007 to that in 2009?
Give a very brief answer. 1.03. What is the ratio of the Balance of Payment (as % of service exports) of North America in 2007 to that in 2010?
Make the answer very short. 1.06. What is the ratio of the Balance of Payment (as % of service exports) in Benin in 2007 to that in 2010?
Provide a succinct answer. 0.16. What is the ratio of the Balance of Payment (as % of service exports) of South Africa in 2007 to that in 2010?
Offer a very short reply. 0.96. What is the ratio of the Balance of Payment (as % of service exports) of North America in 2007 to that in 2011?
Provide a succinct answer. 1.06. What is the ratio of the Balance of Payment (as % of service exports) in Small states in 2007 to that in 2011?
Offer a terse response. 1.15. What is the ratio of the Balance of Payment (as % of service exports) of Benin in 2007 to that in 2011?
Offer a terse response. 0.15. What is the ratio of the Balance of Payment (as % of service exports) of South Africa in 2007 to that in 2011?
Your response must be concise. 0.96. What is the ratio of the Balance of Payment (as % of service exports) of North America in 2008 to that in 2009?
Give a very brief answer. 1.15. What is the ratio of the Balance of Payment (as % of service exports) of Small states in 2008 to that in 2009?
Offer a very short reply. 1.05. What is the ratio of the Balance of Payment (as % of service exports) in Benin in 2008 to that in 2009?
Offer a very short reply. 0.46. What is the ratio of the Balance of Payment (as % of service exports) of South Africa in 2008 to that in 2009?
Give a very brief answer. 1.05. What is the ratio of the Balance of Payment (as % of service exports) in North America in 2008 to that in 2010?
Your response must be concise. 1.1. What is the ratio of the Balance of Payment (as % of service exports) of Small states in 2008 to that in 2010?
Your answer should be compact. 1.05. What is the ratio of the Balance of Payment (as % of service exports) of Benin in 2008 to that in 2010?
Give a very brief answer. 0.14. What is the ratio of the Balance of Payment (as % of service exports) in South Africa in 2008 to that in 2010?
Make the answer very short. 0.98. What is the ratio of the Balance of Payment (as % of service exports) of North America in 2008 to that in 2011?
Give a very brief answer. 1.1. What is the ratio of the Balance of Payment (as % of service exports) in Small states in 2008 to that in 2011?
Your response must be concise. 1.22. What is the ratio of the Balance of Payment (as % of service exports) in Benin in 2008 to that in 2011?
Provide a succinct answer. 0.13. What is the ratio of the Balance of Payment (as % of service exports) in South Africa in 2008 to that in 2011?
Your response must be concise. 0.98. What is the ratio of the Balance of Payment (as % of service exports) in North America in 2009 to that in 2010?
Keep it short and to the point. 0.95. What is the ratio of the Balance of Payment (as % of service exports) of Small states in 2009 to that in 2010?
Offer a terse response. 1. What is the ratio of the Balance of Payment (as % of service exports) of Benin in 2009 to that in 2010?
Your response must be concise. 0.3. What is the ratio of the Balance of Payment (as % of service exports) of South Africa in 2009 to that in 2010?
Provide a succinct answer. 0.93. What is the ratio of the Balance of Payment (as % of service exports) in North America in 2009 to that in 2011?
Your response must be concise. 0.95. What is the ratio of the Balance of Payment (as % of service exports) of Small states in 2009 to that in 2011?
Your response must be concise. 1.16. What is the ratio of the Balance of Payment (as % of service exports) in Benin in 2009 to that in 2011?
Offer a very short reply. 0.29. What is the ratio of the Balance of Payment (as % of service exports) in South Africa in 2009 to that in 2011?
Your answer should be very brief. 0.93. What is the ratio of the Balance of Payment (as % of service exports) of Small states in 2010 to that in 2011?
Your answer should be compact. 1.16. What is the ratio of the Balance of Payment (as % of service exports) in Benin in 2010 to that in 2011?
Keep it short and to the point. 0.97. What is the difference between the highest and the second highest Balance of Payment (as % of service exports) in North America?
Offer a very short reply. 0.24. What is the difference between the highest and the second highest Balance of Payment (as % of service exports) in Small states?
Your answer should be compact. 0.8. What is the difference between the highest and the second highest Balance of Payment (as % of service exports) in Benin?
Offer a terse response. 0.83. What is the difference between the highest and the second highest Balance of Payment (as % of service exports) of South Africa?
Provide a short and direct response. 0.03. What is the difference between the highest and the lowest Balance of Payment (as % of service exports) of North America?
Your answer should be very brief. 2.17. What is the difference between the highest and the lowest Balance of Payment (as % of service exports) of Small states?
Keep it short and to the point. 3.91. What is the difference between the highest and the lowest Balance of Payment (as % of service exports) in Benin?
Ensure brevity in your answer.  23.97. What is the difference between the highest and the lowest Balance of Payment (as % of service exports) of South Africa?
Keep it short and to the point. 2.21. 